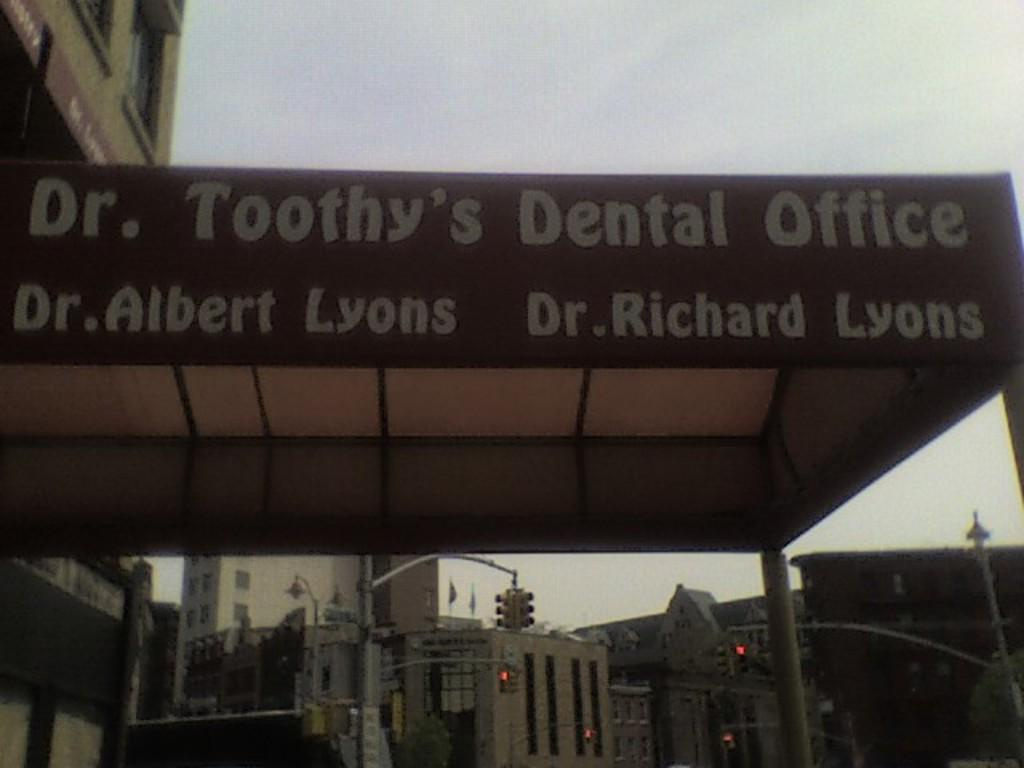What type of structure is in the image with pillars? There is a shed with pillars in the image. What can be seen written on the shed? Something is written on the shed. What kind of buildings can be seen in the background of the image? There are buildings with windows in the background of the image. What type of traffic control device is present in the background of the image? Traffic lights with poles are present in the background of the image. What is visible in the sky in the background of the image? The sky is visible in the background of the image. What type of muscle is being exercised by the cow in the image? There is no cow present in the image, so it is not possible to determine which muscle might be exercised. 